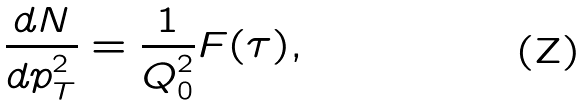<formula> <loc_0><loc_0><loc_500><loc_500>\frac { d N } { d p ^ { 2 } _ { T } } = \frac { 1 } { Q ^ { 2 } _ { 0 } } F ( \tau ) ,</formula> 